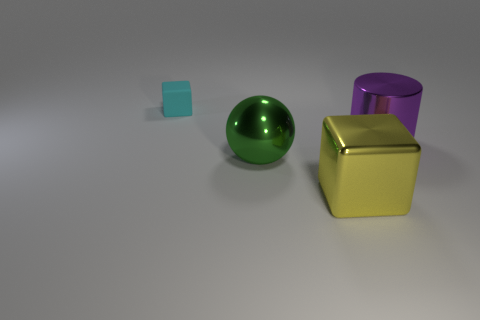Is there any other thing that has the same material as the big green sphere?
Ensure brevity in your answer.  Yes. Is the small cube made of the same material as the big cylinder?
Your answer should be compact. No. The large metal thing behind the big thing left of the cube that is in front of the big purple object is what shape?
Your answer should be very brief. Cylinder. There is a thing that is behind the big green thing and on the right side of the cyan matte object; what is its material?
Your response must be concise. Metal. There is a big thing behind the metal thing that is to the left of the block that is on the right side of the metal sphere; what is its color?
Your answer should be compact. Purple. What number of purple objects are either blocks or large cylinders?
Offer a very short reply. 1. How many other things are the same size as the metallic sphere?
Keep it short and to the point. 2. How many tiny green matte balls are there?
Make the answer very short. 0. Are there any other things that are the same shape as the yellow thing?
Provide a succinct answer. Yes. Is the material of the large object that is to the left of the big yellow cube the same as the block that is in front of the small cyan rubber block?
Your answer should be compact. Yes. 